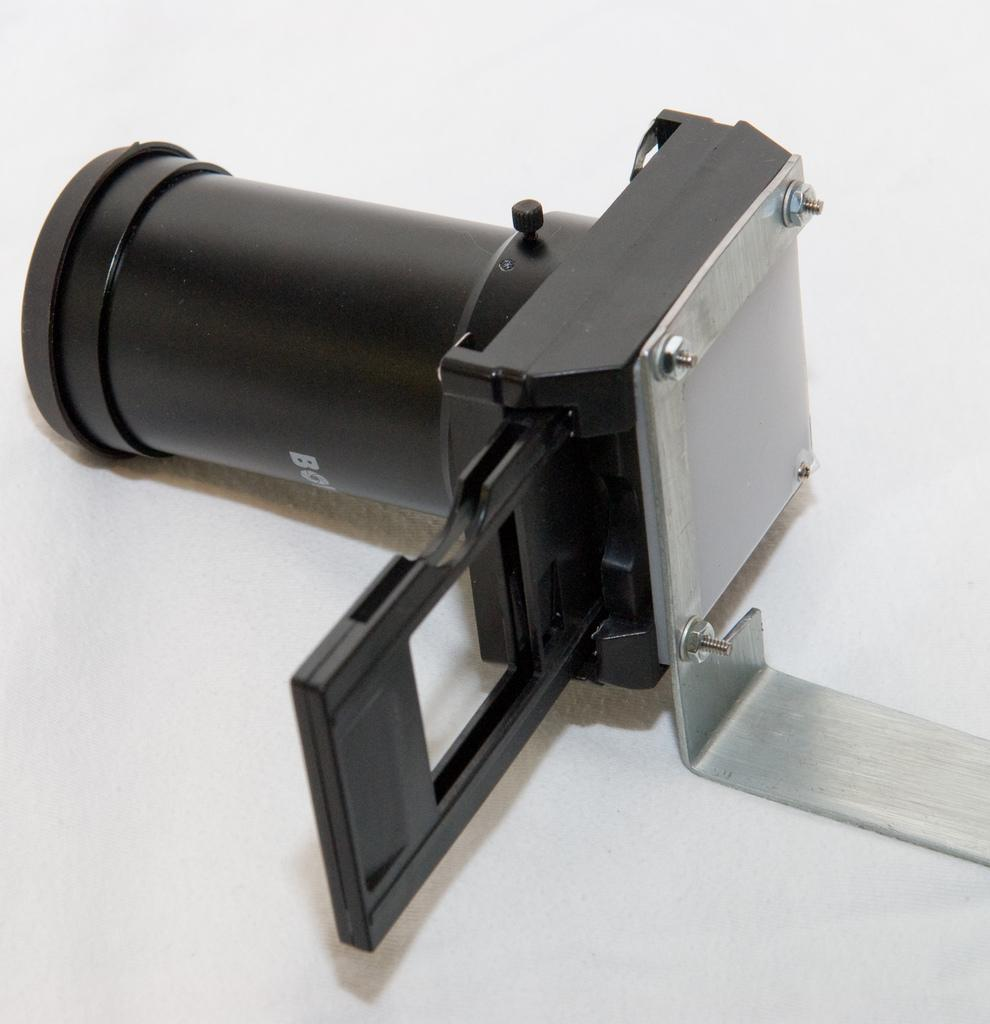What is the color of the object in the image? The object in the image is black in color. What is the color of the surface the object is placed on? The surface is white in color. What type of surface is the object placed on? The white color surface appears to be a table. What type of appliance is placed on the bridge in the image? There is no appliance or bridge present in the image; it only features a black object placed on a white table. 